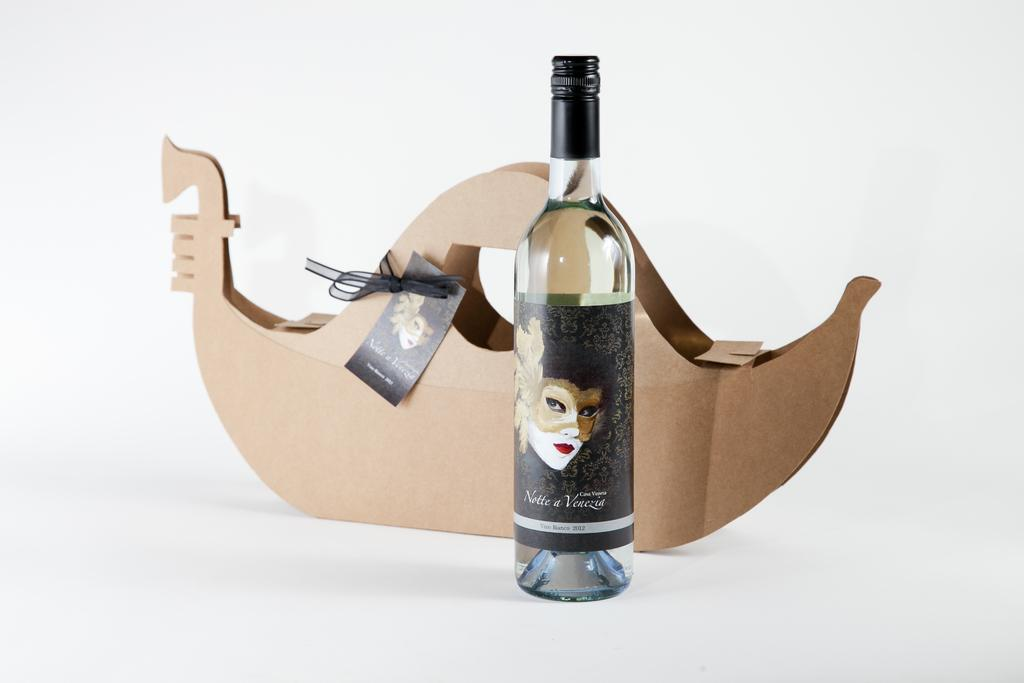<image>
Give a short and clear explanation of the subsequent image. a wine bottle with the year 2012 on it 